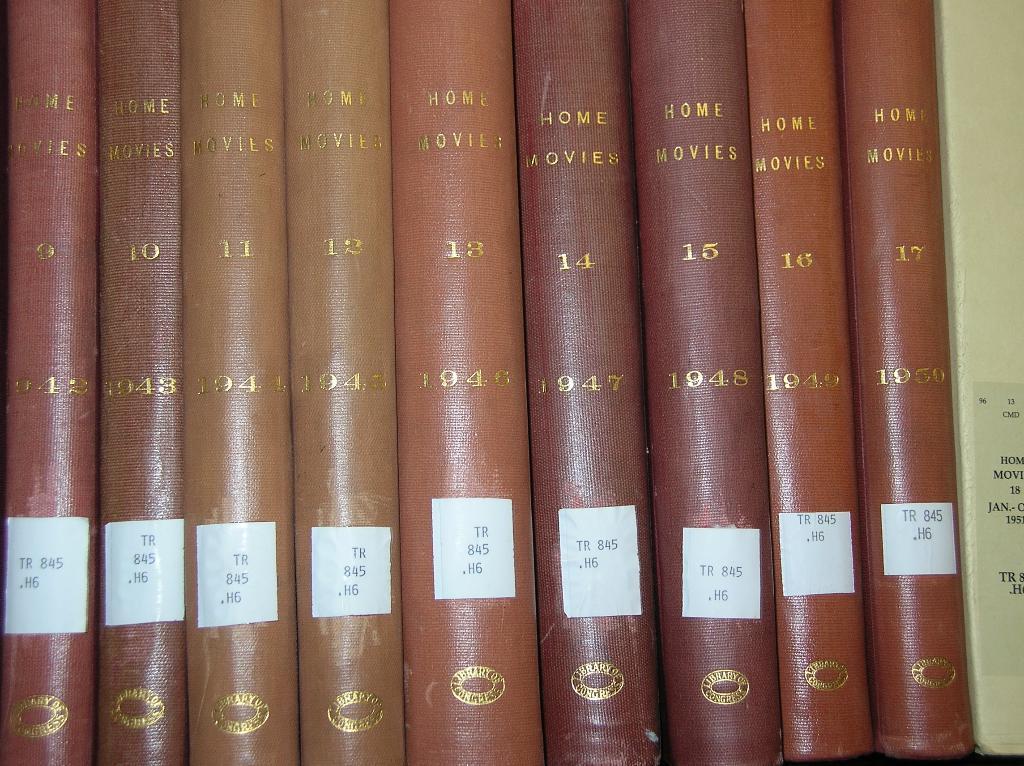Which year is on the far right?
Give a very brief answer. 1950. 